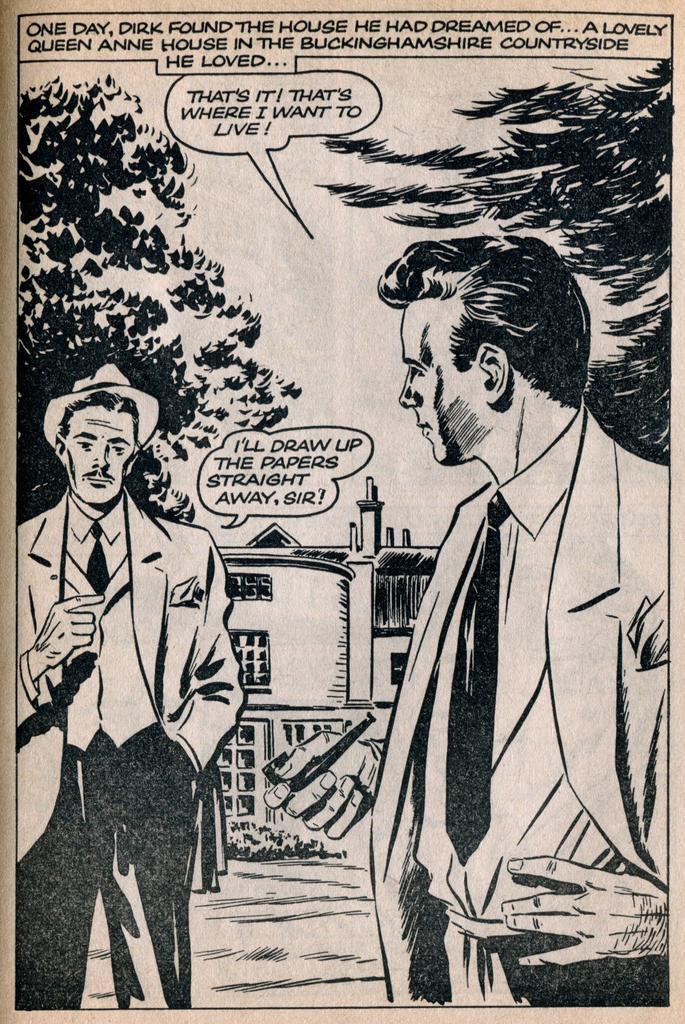Please provide a concise description of this image. This is a poster, on this poster we can see people, trees, building and some text on it. 